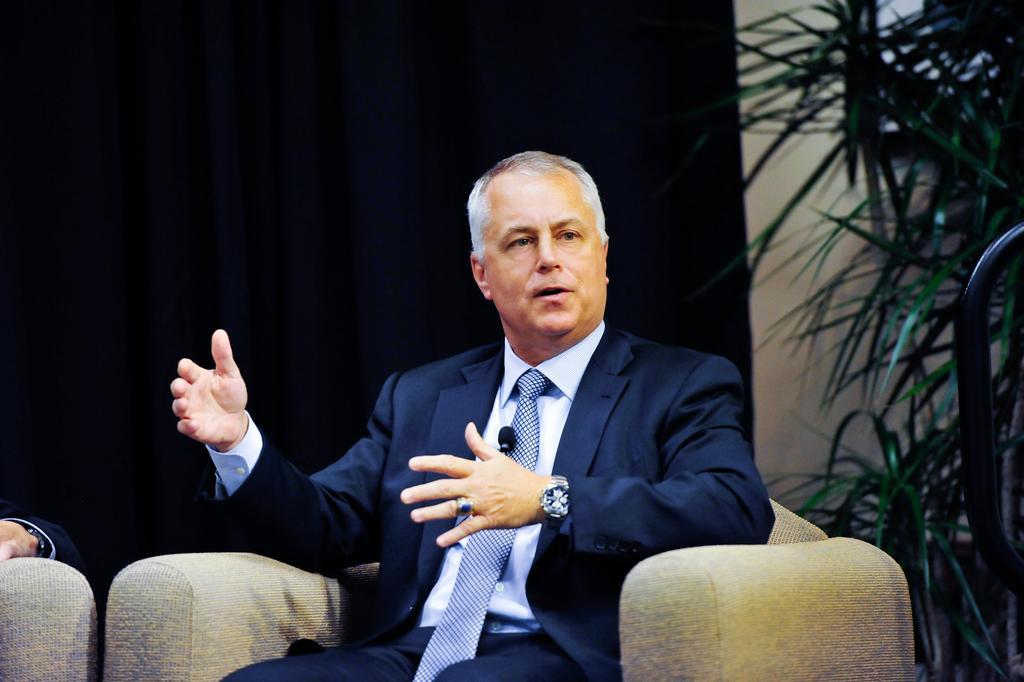How would you summarize this image in a sentence or two? In the picture I can see a man sitting on a chair. The man is wearing a tie, a shirt, a coat and a watch. In the background I can see a plant and some other objects.
. 